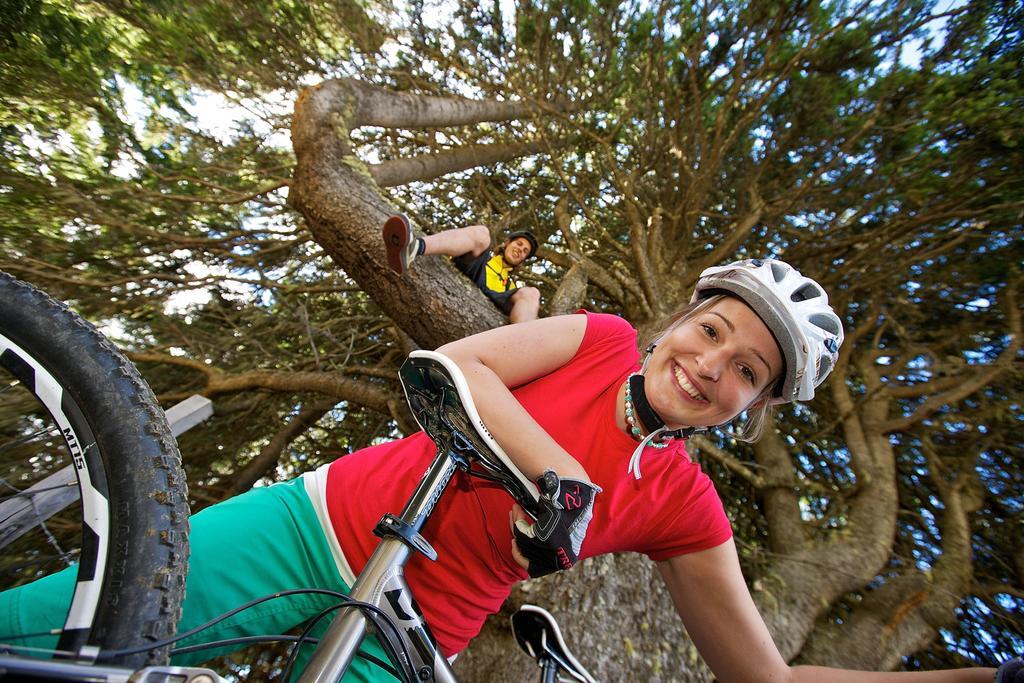Could you give a brief overview of what you see in this image? There are two people in the picture, The one is on the tree and the other is on the floor holding a bicycle who wore a helmet and hand gloves. 